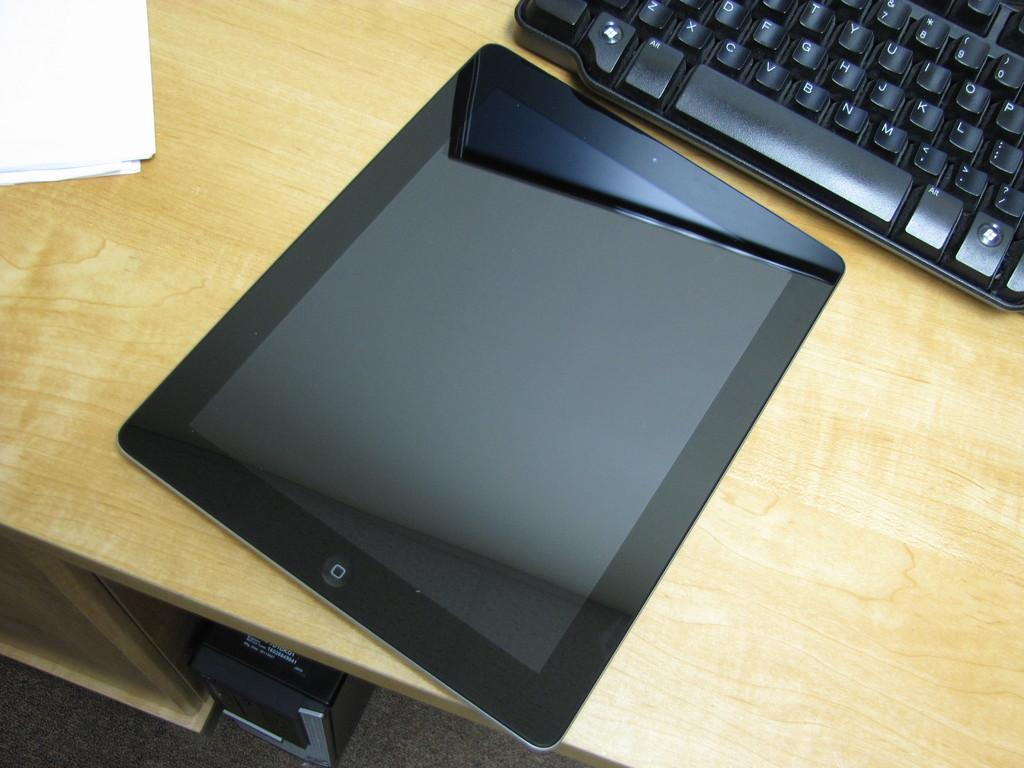<image>
Offer a succinct explanation of the picture presented. A tablet and keyboard with the letters T to P showing in the top row. 